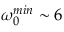<formula> <loc_0><loc_0><loc_500><loc_500>\omega _ { 0 } ^ { \min } \sim 6</formula> 